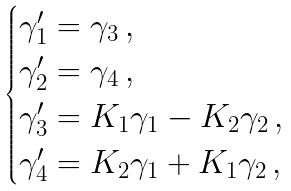<formula> <loc_0><loc_0><loc_500><loc_500>\begin{cases} \gamma ^ { \prime } _ { 1 } = \gamma _ { 3 } \, , \\ \gamma ^ { \prime } _ { 2 } = \gamma _ { 4 } \, , \\ \gamma ^ { \prime } _ { 3 } = K _ { 1 } \gamma _ { 1 } - K _ { 2 } \gamma _ { 2 } \, , \\ \gamma ^ { \prime } _ { 4 } = K _ { 2 } \gamma _ { 1 } + K _ { 1 } \gamma _ { 2 } \, , \end{cases}</formula> 